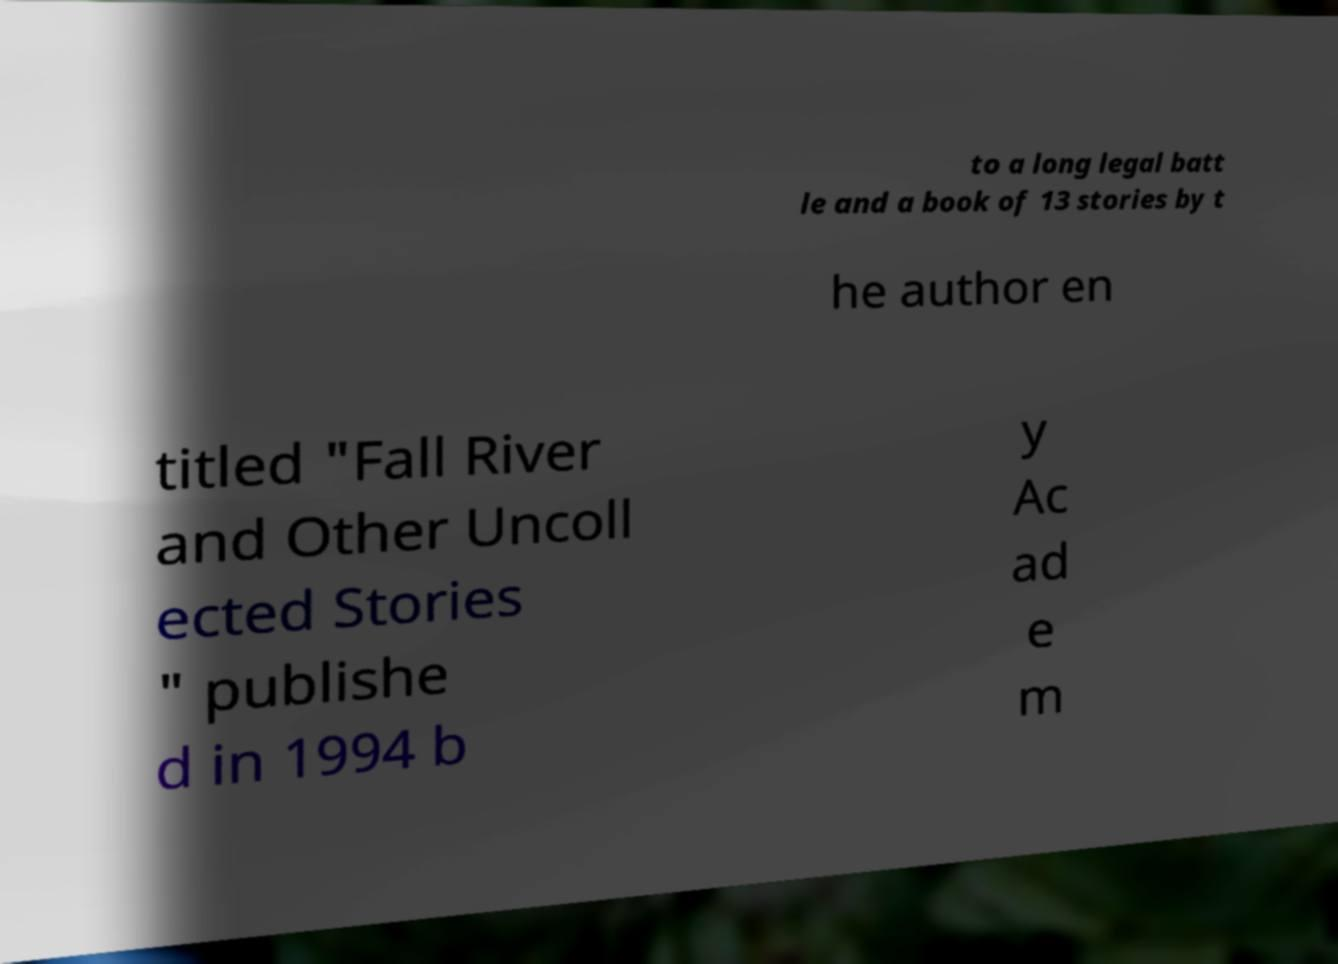For documentation purposes, I need the text within this image transcribed. Could you provide that? to a long legal batt le and a book of 13 stories by t he author en titled "Fall River and Other Uncoll ected Stories " publishe d in 1994 b y Ac ad e m 